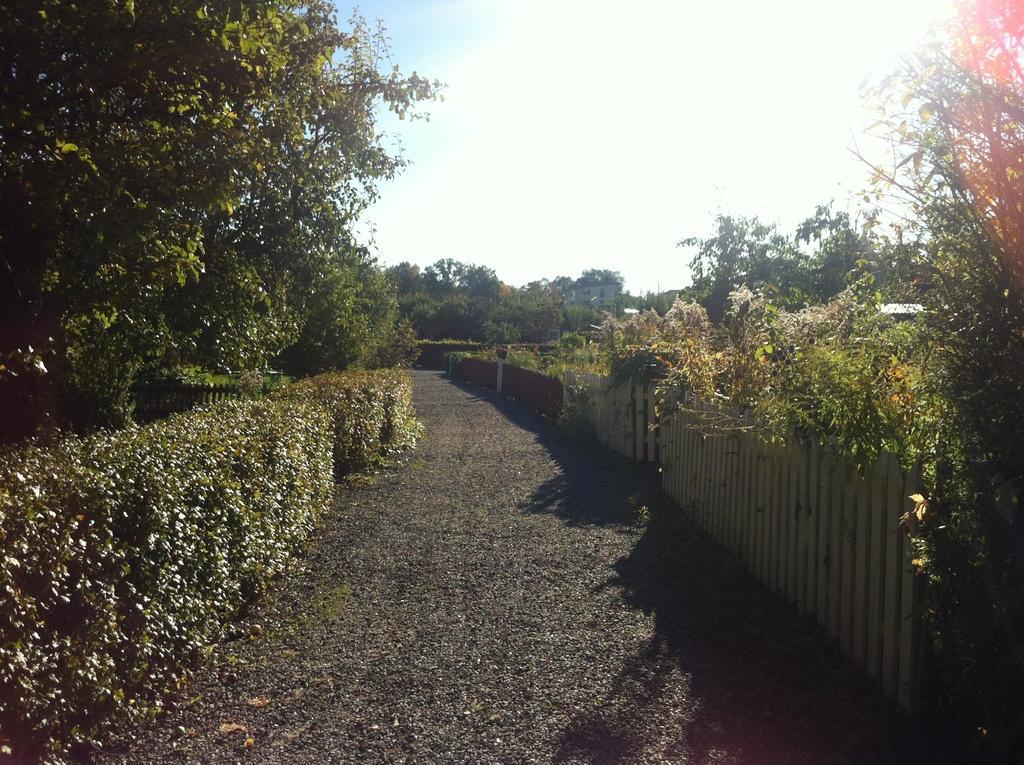Please provide a concise description of this image. In the center of the image there is a road. On the right side of the image there is a metal fence. There are plants. In the background of the image there are trees, buildings and sky. 